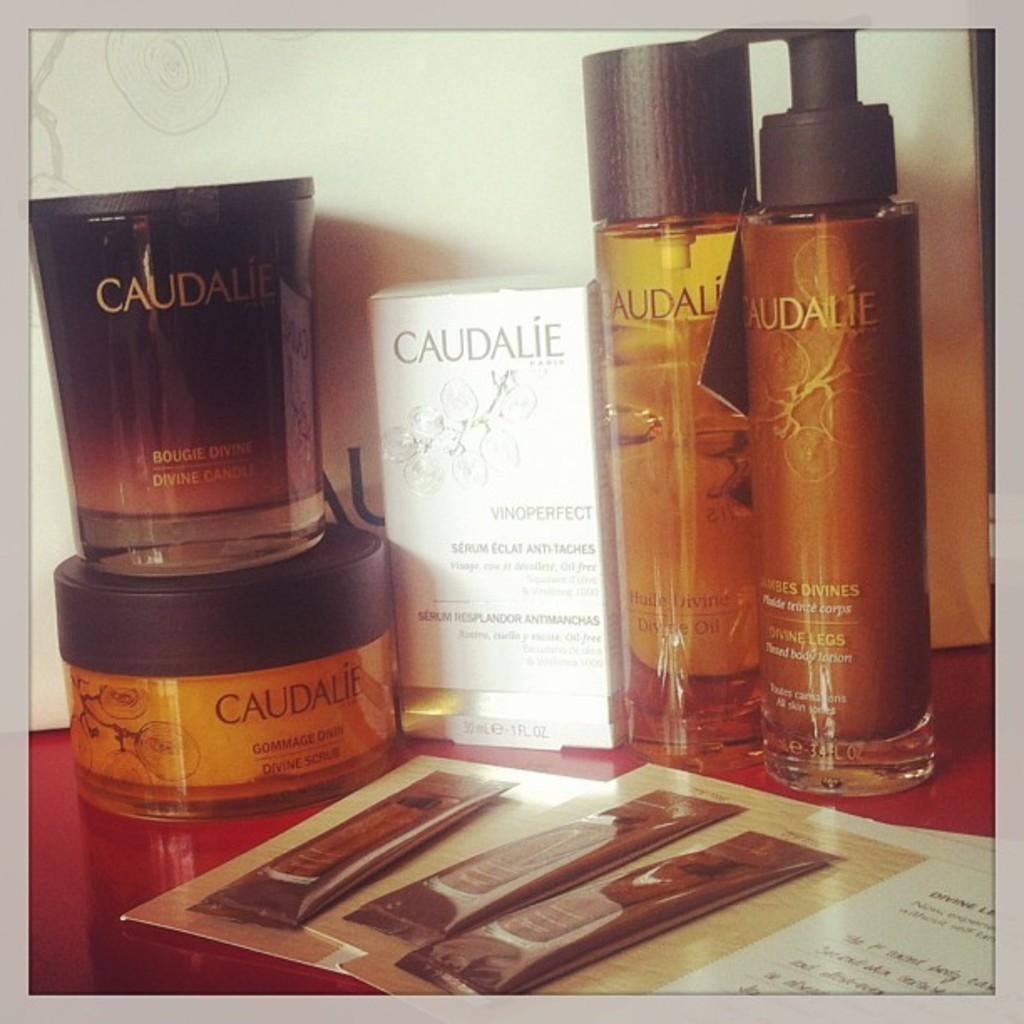What is the brand on the white box?
Make the answer very short. Caudalie. 